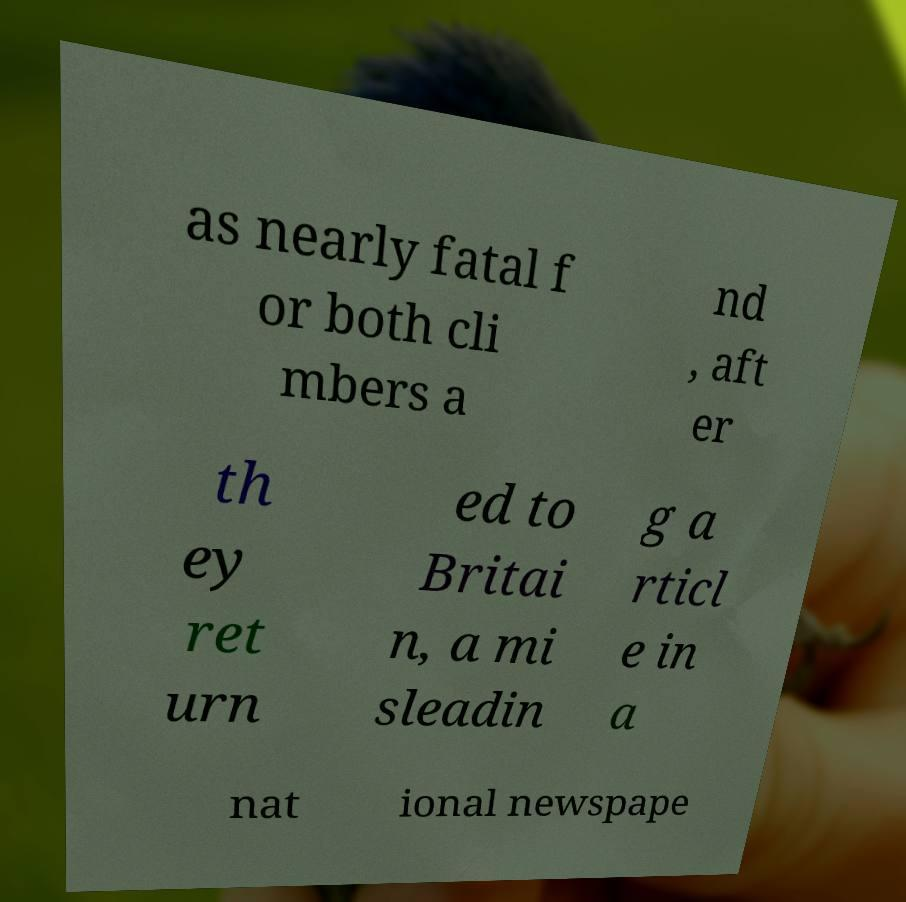Can you accurately transcribe the text from the provided image for me? as nearly fatal f or both cli mbers a nd , aft er th ey ret urn ed to Britai n, a mi sleadin g a rticl e in a nat ional newspape 